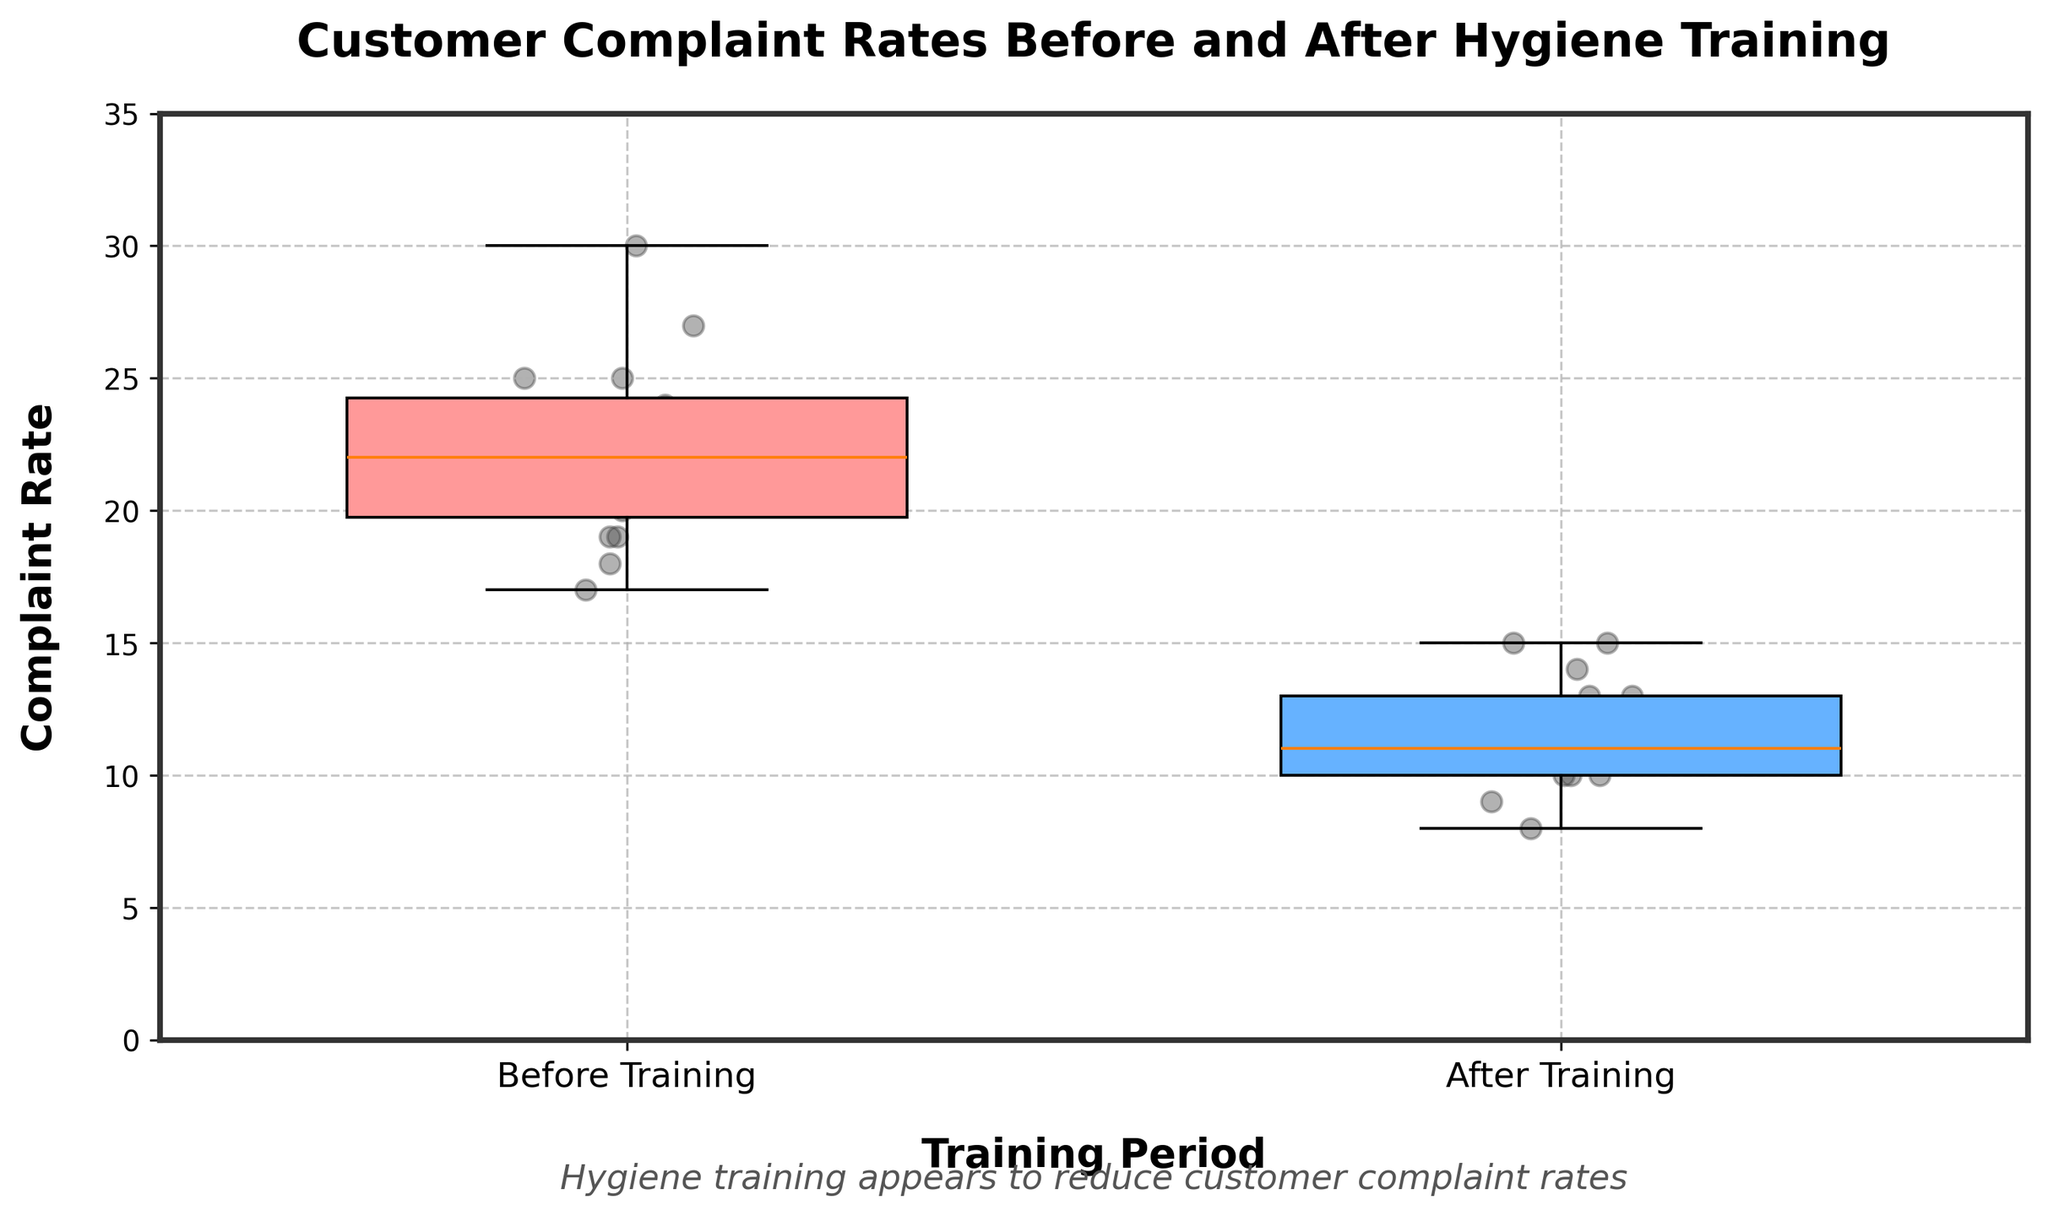What are the colors of the boxplots? The colors of the boxplots can be seen by looking at the filled areas of each box. The "Before Training" box is light red, and the "After Training" box is light blue.
Answer: Light red and light blue What is the title of the plot? The title is located at the top of the plot and it states "Customer Complaint Rates Before and After Hygiene Training".
Answer: Customer Complaint Rates Before and After Hygiene Training How many periods are represented in the boxplot, and what are they? The x-axis labels indicate the two periods represented: "Before Training" and "After Training".
Answer: Two periods: Before Training and After Training Which period has the higher median complaint rate? The median can be identified by the central line within each boxplot. The boxplot for "Before Training" has a higher central line compared to "After Training's" boxplot.
Answer: Before Training What is the general trend observed between the complaint rates before and after training? By comparing the positions of the boxplots and their spread, it's clear that complaint rates generally decrease after hygiene training, as the box for "After Training" has lower values compared to "Before Training".
Answer: Decrease What is the range of the complaint rates for 'Before Training'? The range can be determined by looking at the span of the boxplot and the whiskers. The lowest point is 18 and the highest point is 30.
Answer: 18 to 30 Which period shows more variability in complaint rates? Variability can be assessed by the spread of each boxplot. The "Before Training" boxplot is more spread out, indicating more variability compared to the tighter spread in "After Training".
Answer: Before Training Do any periods have outliers, and if so, which ones? Outliers would be represented as individual points outside the whiskers, but the plot does not show any outlier points for either period.
Answer: No outliers Comparing the 'Before Training' and 'After Training' periods, what is the approximate median difference in complaint rates? The median difference can be calculated by comparing the central lines of both boxplots. The median for "Before Training" is around 22-23, while "After Training" is around 11-12, so the difference is approximately 11.
Answer: Approximately 11 